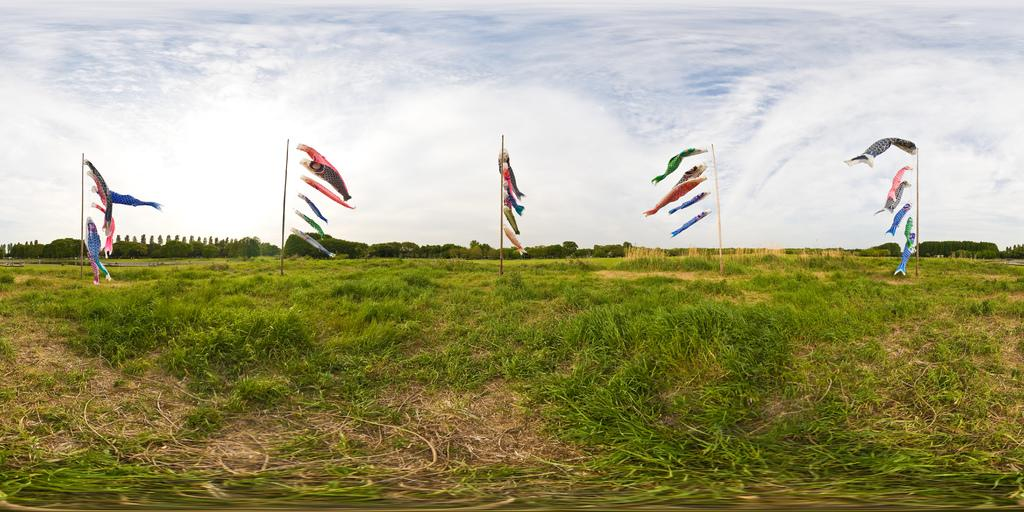What type of surface can be seen in the image? The ground is visible in the image. What type of vegetation is present in the image? There is grass, plants, and trees in the image. What are the poles with objects in the image used for? The purpose of the poles with objects is not specified in the image. What is visible in the sky in the image? The sky is visible in the image, and clouds are present. What advice does the stranger give to the person in the image? There is no stranger present in the image, so no advice can be given. What color is the silver object on the pole in the image? There is no silver object present on the pole in the image. 